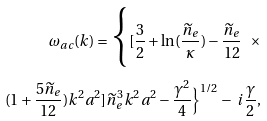Convert formula to latex. <formula><loc_0><loc_0><loc_500><loc_500>\omega _ { a c } ( k ) = \Big { \{ } [ \frac { 3 } { 2 } + \ln ( \frac { \widetilde { n } _ { e } } { \kappa } ) - \frac { \widetilde { n } _ { e } } { 1 2 } \ \times \\ ( 1 + \frac { 5 \widetilde { n } _ { e } } { 1 2 } ) k ^ { 2 } a ^ { 2 } ] { \widetilde { n } _ { e } } ^ { 3 } k ^ { 2 } a ^ { 2 } - \frac { \gamma ^ { 2 } } { 4 } \Big { \} } ^ { 1 / 2 } - \ i \frac { \gamma } { 2 } ,</formula> 